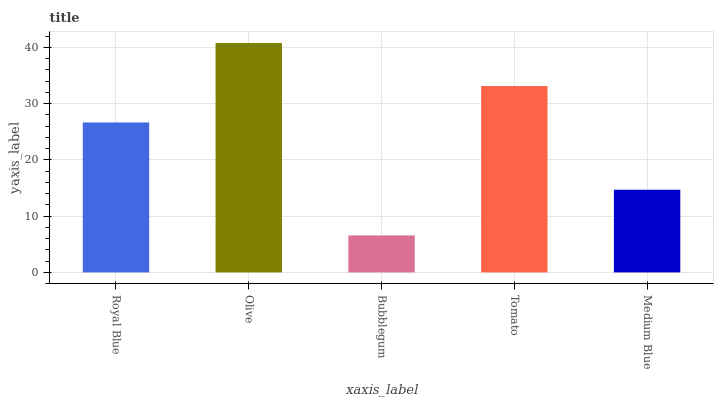Is Bubblegum the minimum?
Answer yes or no. Yes. Is Olive the maximum?
Answer yes or no. Yes. Is Olive the minimum?
Answer yes or no. No. Is Bubblegum the maximum?
Answer yes or no. No. Is Olive greater than Bubblegum?
Answer yes or no. Yes. Is Bubblegum less than Olive?
Answer yes or no. Yes. Is Bubblegum greater than Olive?
Answer yes or no. No. Is Olive less than Bubblegum?
Answer yes or no. No. Is Royal Blue the high median?
Answer yes or no. Yes. Is Royal Blue the low median?
Answer yes or no. Yes. Is Bubblegum the high median?
Answer yes or no. No. Is Olive the low median?
Answer yes or no. No. 